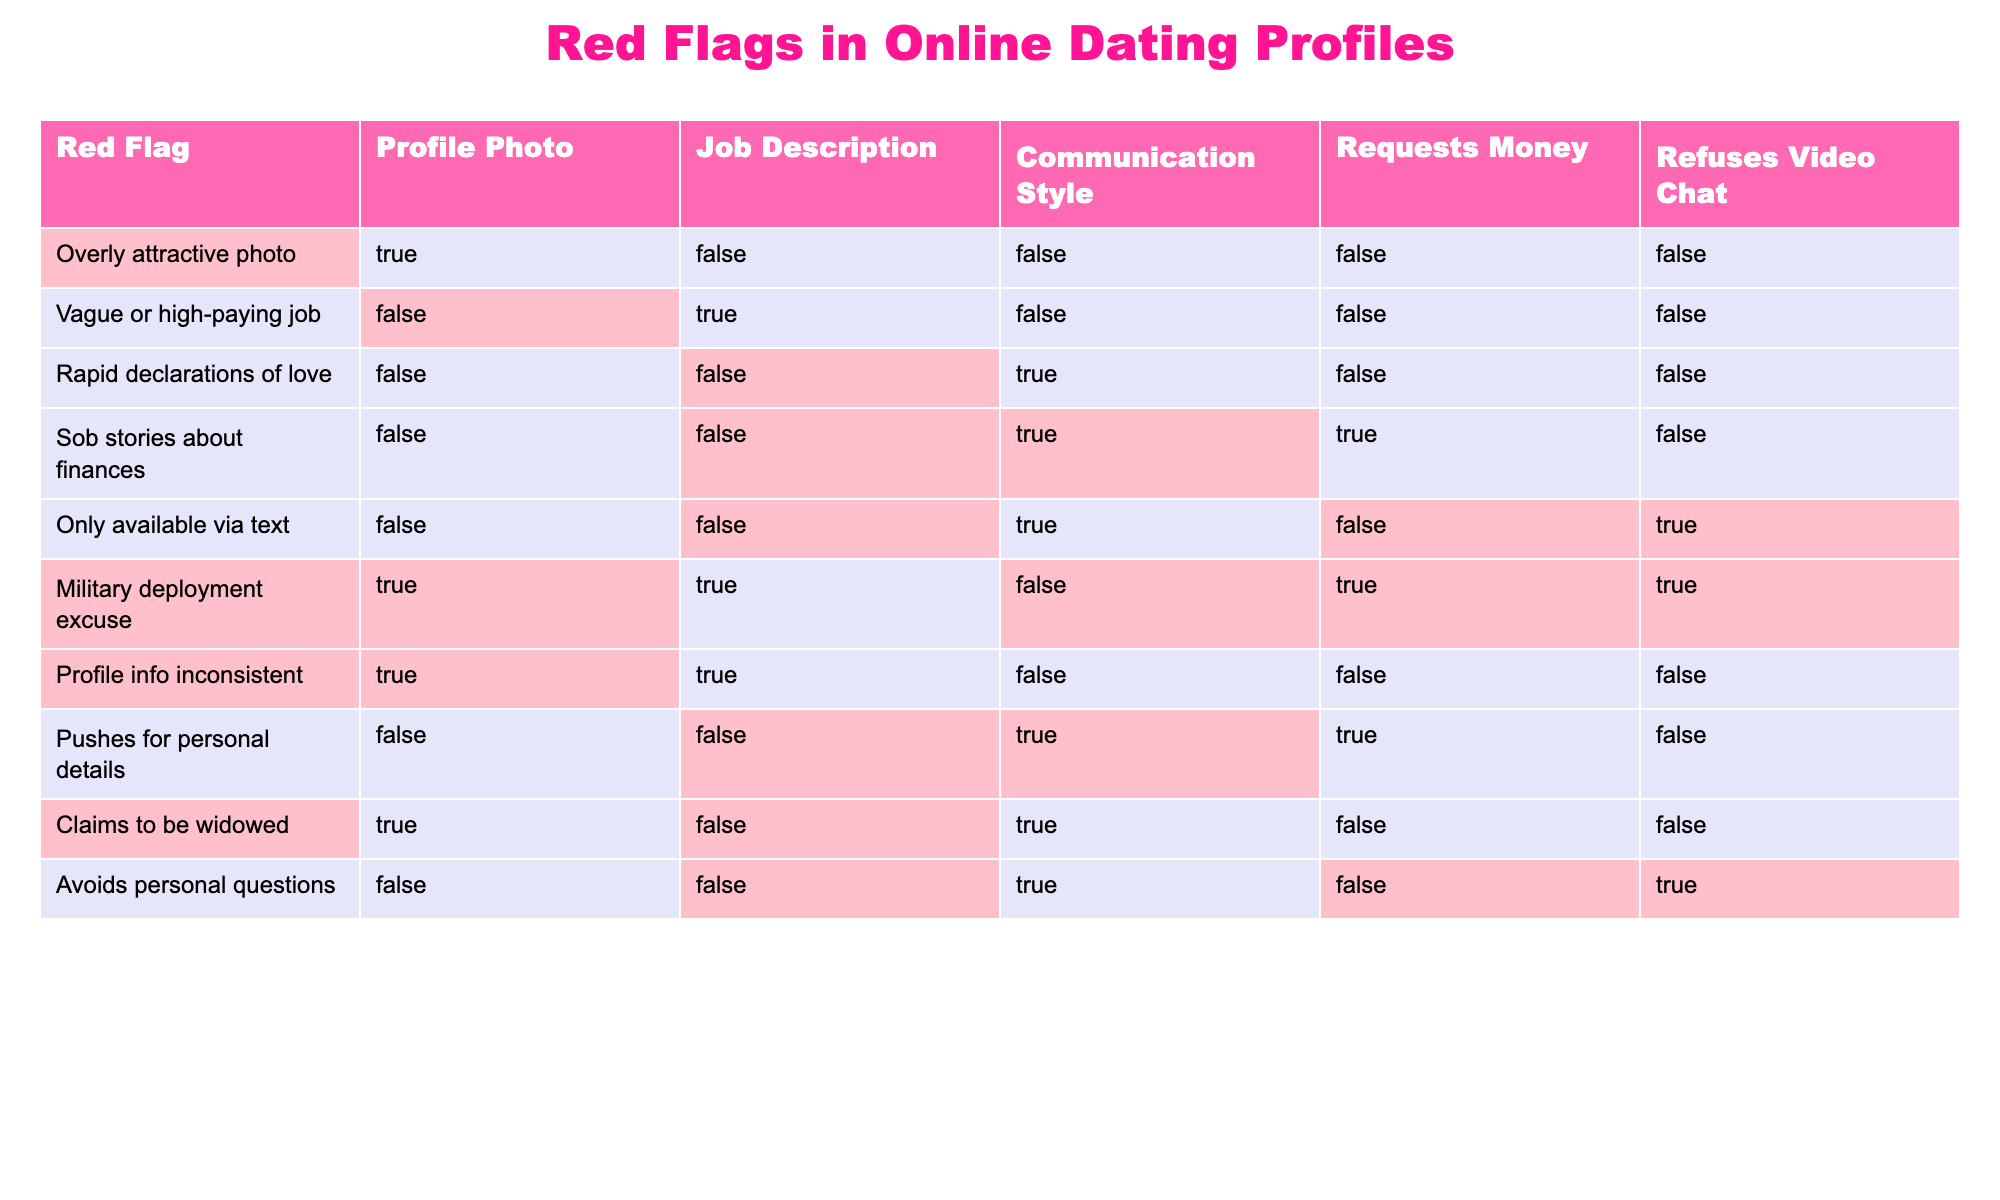What is the total number of flags involving requests for money? There are two rows in the table that indicate requests for money: "Sob stories about finances" and "Military deployment excuse." The total number of flags that involve requests for money is 2.
Answer: 2 How many profiles claim to be widowed? The table shows that only one profile, labeled "Claims to be widowed," explicitly states this condition. Thus, there is only 1 profile that claims this.
Answer: 1 Is there any profile that avoids personal questions and also refuses video chat? Yes, there is a profile titled "Avoids personal questions" where it states that the individual refuses video chat. Therefore, the answer is yes.
Answer: Yes What percentage of the profiles have overly attractive photos? There are 10 profiles in total, and only 1 profile, "Overly attractive photo," has this characteristic, which translates to (1/10)*100 = 10%.
Answer: 10% Which red flag has the highest combination of refusing video chat and requesting money? The "Military deployment excuse" flag indicates both requesting money and refusing video chat. Analyzing the table, it shows these two conditions are present together here, making it the highest combination at 1 instance.
Answer: 1 